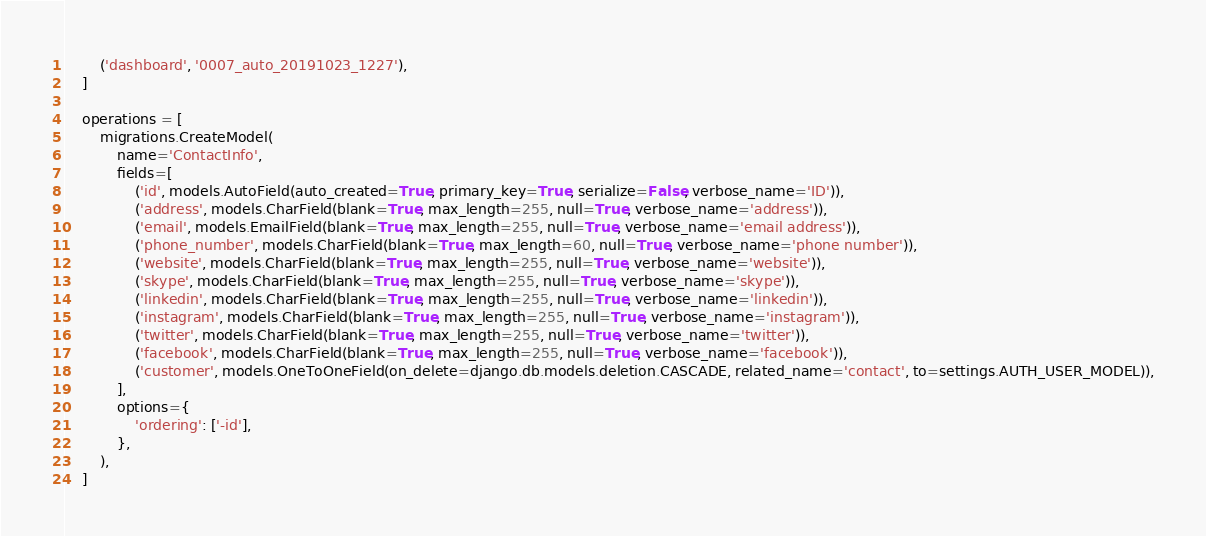Convert code to text. <code><loc_0><loc_0><loc_500><loc_500><_Python_>        ('dashboard', '0007_auto_20191023_1227'),
    ]

    operations = [
        migrations.CreateModel(
            name='ContactInfo',
            fields=[
                ('id', models.AutoField(auto_created=True, primary_key=True, serialize=False, verbose_name='ID')),
                ('address', models.CharField(blank=True, max_length=255, null=True, verbose_name='address')),
                ('email', models.EmailField(blank=True, max_length=255, null=True, verbose_name='email address')),
                ('phone_number', models.CharField(blank=True, max_length=60, null=True, verbose_name='phone number')),
                ('website', models.CharField(blank=True, max_length=255, null=True, verbose_name='website')),
                ('skype', models.CharField(blank=True, max_length=255, null=True, verbose_name='skype')),
                ('linkedin', models.CharField(blank=True, max_length=255, null=True, verbose_name='linkedin')),
                ('instagram', models.CharField(blank=True, max_length=255, null=True, verbose_name='instagram')),
                ('twitter', models.CharField(blank=True, max_length=255, null=True, verbose_name='twitter')),
                ('facebook', models.CharField(blank=True, max_length=255, null=True, verbose_name='facebook')),
                ('customer', models.OneToOneField(on_delete=django.db.models.deletion.CASCADE, related_name='contact', to=settings.AUTH_USER_MODEL)),
            ],
            options={
                'ordering': ['-id'],
            },
        ),
    ]
</code> 